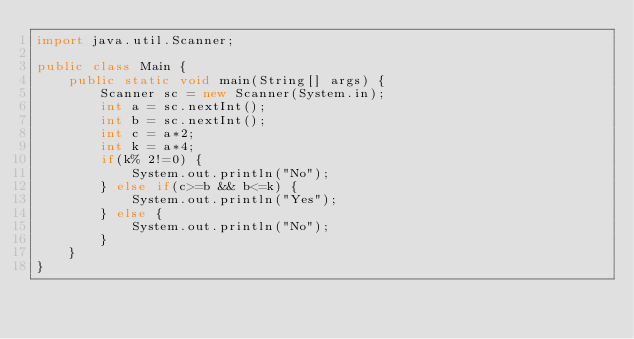Convert code to text. <code><loc_0><loc_0><loc_500><loc_500><_Java_>import java.util.Scanner;
 
public class Main {
    public static void main(String[] args) {
        Scanner sc = new Scanner(System.in);
        int a = sc.nextInt();
        int b = sc.nextInt();
        int c = a*2;
        int k = a*4;
        if(k% 2!=0) {
            System.out.println("No");
        } else if(c>=b && b<=k) {
            System.out.println("Yes");
        } else {
            System.out.println("No");
        }
    }
}</code> 